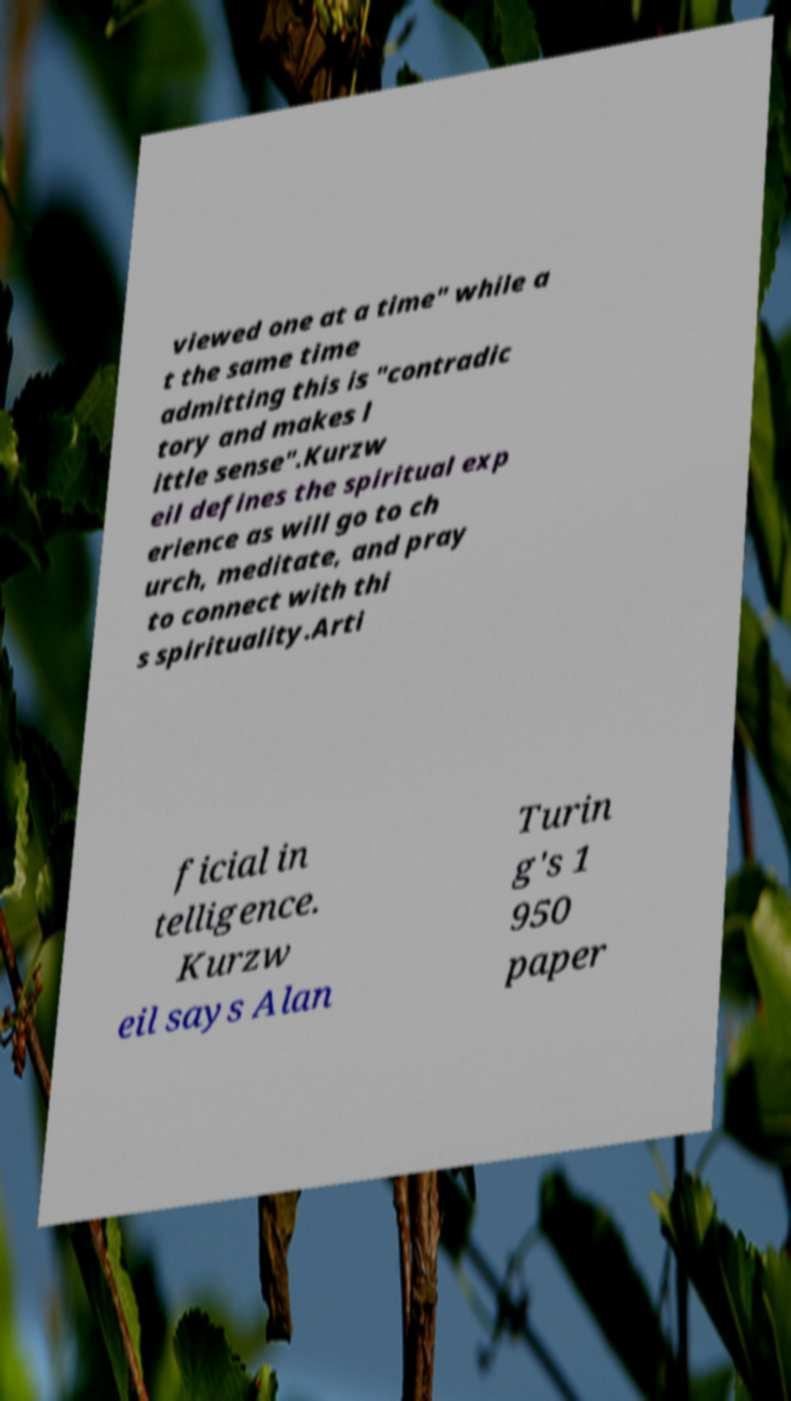I need the written content from this picture converted into text. Can you do that? viewed one at a time" while a t the same time admitting this is "contradic tory and makes l ittle sense".Kurzw eil defines the spiritual exp erience as will go to ch urch, meditate, and pray to connect with thi s spirituality.Arti ficial in telligence. Kurzw eil says Alan Turin g's 1 950 paper 